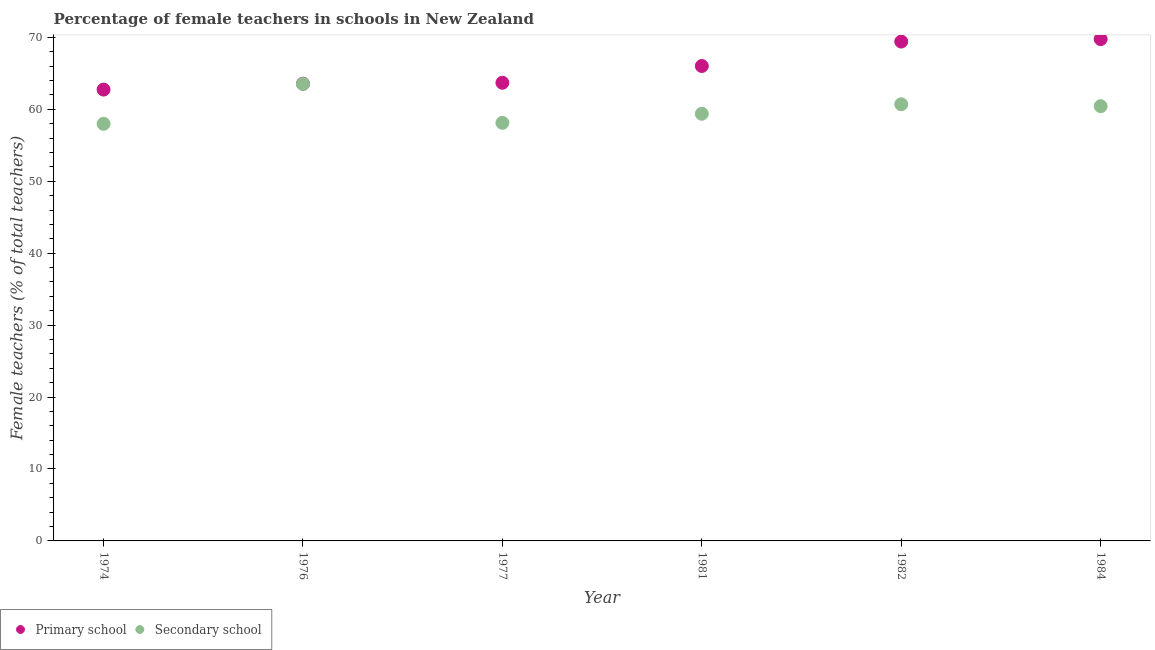Is the number of dotlines equal to the number of legend labels?
Your answer should be compact. Yes. What is the percentage of female teachers in secondary schools in 1984?
Ensure brevity in your answer.  60.43. Across all years, what is the maximum percentage of female teachers in secondary schools?
Keep it short and to the point. 63.51. Across all years, what is the minimum percentage of female teachers in secondary schools?
Your answer should be compact. 57.98. In which year was the percentage of female teachers in primary schools minimum?
Your response must be concise. 1974. What is the total percentage of female teachers in secondary schools in the graph?
Provide a succinct answer. 360.13. What is the difference between the percentage of female teachers in primary schools in 1976 and that in 1977?
Offer a terse response. -0.13. What is the difference between the percentage of female teachers in primary schools in 1974 and the percentage of female teachers in secondary schools in 1984?
Ensure brevity in your answer.  2.31. What is the average percentage of female teachers in primary schools per year?
Your answer should be compact. 65.86. In the year 1974, what is the difference between the percentage of female teachers in primary schools and percentage of female teachers in secondary schools?
Provide a short and direct response. 4.76. In how many years, is the percentage of female teachers in secondary schools greater than 28 %?
Provide a succinct answer. 6. What is the ratio of the percentage of female teachers in primary schools in 1977 to that in 1981?
Provide a short and direct response. 0.96. Is the percentage of female teachers in secondary schools in 1977 less than that in 1982?
Give a very brief answer. Yes. What is the difference between the highest and the second highest percentage of female teachers in primary schools?
Ensure brevity in your answer.  0.34. What is the difference between the highest and the lowest percentage of female teachers in secondary schools?
Provide a short and direct response. 5.53. Is the percentage of female teachers in primary schools strictly greater than the percentage of female teachers in secondary schools over the years?
Offer a very short reply. Yes. How many years are there in the graph?
Your answer should be compact. 6. What is the difference between two consecutive major ticks on the Y-axis?
Provide a short and direct response. 10. Are the values on the major ticks of Y-axis written in scientific E-notation?
Your answer should be very brief. No. How many legend labels are there?
Your response must be concise. 2. What is the title of the graph?
Your response must be concise. Percentage of female teachers in schools in New Zealand. Does "Primary education" appear as one of the legend labels in the graph?
Offer a terse response. No. What is the label or title of the X-axis?
Your answer should be compact. Year. What is the label or title of the Y-axis?
Your answer should be compact. Female teachers (% of total teachers). What is the Female teachers (% of total teachers) of Primary school in 1974?
Give a very brief answer. 62.74. What is the Female teachers (% of total teachers) of Secondary school in 1974?
Provide a succinct answer. 57.98. What is the Female teachers (% of total teachers) in Primary school in 1976?
Ensure brevity in your answer.  63.56. What is the Female teachers (% of total teachers) in Secondary school in 1976?
Offer a very short reply. 63.51. What is the Female teachers (% of total teachers) in Primary school in 1977?
Your answer should be compact. 63.69. What is the Female teachers (% of total teachers) in Secondary school in 1977?
Give a very brief answer. 58.12. What is the Female teachers (% of total teachers) of Primary school in 1981?
Your response must be concise. 66.02. What is the Female teachers (% of total teachers) of Secondary school in 1981?
Provide a short and direct response. 59.38. What is the Female teachers (% of total teachers) in Primary school in 1982?
Offer a terse response. 69.42. What is the Female teachers (% of total teachers) of Secondary school in 1982?
Your response must be concise. 60.7. What is the Female teachers (% of total teachers) of Primary school in 1984?
Give a very brief answer. 69.76. What is the Female teachers (% of total teachers) of Secondary school in 1984?
Provide a short and direct response. 60.43. Across all years, what is the maximum Female teachers (% of total teachers) of Primary school?
Keep it short and to the point. 69.76. Across all years, what is the maximum Female teachers (% of total teachers) in Secondary school?
Give a very brief answer. 63.51. Across all years, what is the minimum Female teachers (% of total teachers) of Primary school?
Provide a short and direct response. 62.74. Across all years, what is the minimum Female teachers (% of total teachers) of Secondary school?
Offer a very short reply. 57.98. What is the total Female teachers (% of total teachers) in Primary school in the graph?
Your answer should be compact. 395.19. What is the total Female teachers (% of total teachers) in Secondary school in the graph?
Ensure brevity in your answer.  360.13. What is the difference between the Female teachers (% of total teachers) of Primary school in 1974 and that in 1976?
Provide a succinct answer. -0.82. What is the difference between the Female teachers (% of total teachers) of Secondary school in 1974 and that in 1976?
Offer a very short reply. -5.53. What is the difference between the Female teachers (% of total teachers) of Primary school in 1974 and that in 1977?
Ensure brevity in your answer.  -0.95. What is the difference between the Female teachers (% of total teachers) of Secondary school in 1974 and that in 1977?
Make the answer very short. -0.13. What is the difference between the Female teachers (% of total teachers) in Primary school in 1974 and that in 1981?
Make the answer very short. -3.28. What is the difference between the Female teachers (% of total teachers) of Secondary school in 1974 and that in 1981?
Make the answer very short. -1.4. What is the difference between the Female teachers (% of total teachers) of Primary school in 1974 and that in 1982?
Offer a very short reply. -6.67. What is the difference between the Female teachers (% of total teachers) of Secondary school in 1974 and that in 1982?
Your response must be concise. -2.72. What is the difference between the Female teachers (% of total teachers) of Primary school in 1974 and that in 1984?
Offer a terse response. -7.02. What is the difference between the Female teachers (% of total teachers) in Secondary school in 1974 and that in 1984?
Your answer should be very brief. -2.45. What is the difference between the Female teachers (% of total teachers) of Primary school in 1976 and that in 1977?
Give a very brief answer. -0.13. What is the difference between the Female teachers (% of total teachers) in Secondary school in 1976 and that in 1977?
Offer a terse response. 5.4. What is the difference between the Female teachers (% of total teachers) of Primary school in 1976 and that in 1981?
Offer a very short reply. -2.45. What is the difference between the Female teachers (% of total teachers) in Secondary school in 1976 and that in 1981?
Provide a short and direct response. 4.13. What is the difference between the Female teachers (% of total teachers) of Primary school in 1976 and that in 1982?
Keep it short and to the point. -5.85. What is the difference between the Female teachers (% of total teachers) of Secondary school in 1976 and that in 1982?
Your response must be concise. 2.81. What is the difference between the Female teachers (% of total teachers) in Primary school in 1976 and that in 1984?
Provide a succinct answer. -6.19. What is the difference between the Female teachers (% of total teachers) in Secondary school in 1976 and that in 1984?
Provide a short and direct response. 3.08. What is the difference between the Female teachers (% of total teachers) of Primary school in 1977 and that in 1981?
Provide a short and direct response. -2.33. What is the difference between the Female teachers (% of total teachers) of Secondary school in 1977 and that in 1981?
Give a very brief answer. -1.26. What is the difference between the Female teachers (% of total teachers) in Primary school in 1977 and that in 1982?
Give a very brief answer. -5.73. What is the difference between the Female teachers (% of total teachers) in Secondary school in 1977 and that in 1982?
Keep it short and to the point. -2.58. What is the difference between the Female teachers (% of total teachers) of Primary school in 1977 and that in 1984?
Give a very brief answer. -6.07. What is the difference between the Female teachers (% of total teachers) in Secondary school in 1977 and that in 1984?
Your response must be concise. -2.32. What is the difference between the Female teachers (% of total teachers) of Primary school in 1981 and that in 1982?
Your answer should be compact. -3.4. What is the difference between the Female teachers (% of total teachers) of Secondary school in 1981 and that in 1982?
Provide a short and direct response. -1.32. What is the difference between the Female teachers (% of total teachers) of Primary school in 1981 and that in 1984?
Keep it short and to the point. -3.74. What is the difference between the Female teachers (% of total teachers) in Secondary school in 1981 and that in 1984?
Offer a very short reply. -1.05. What is the difference between the Female teachers (% of total teachers) of Primary school in 1982 and that in 1984?
Provide a short and direct response. -0.34. What is the difference between the Female teachers (% of total teachers) of Secondary school in 1982 and that in 1984?
Make the answer very short. 0.27. What is the difference between the Female teachers (% of total teachers) of Primary school in 1974 and the Female teachers (% of total teachers) of Secondary school in 1976?
Keep it short and to the point. -0.77. What is the difference between the Female teachers (% of total teachers) of Primary school in 1974 and the Female teachers (% of total teachers) of Secondary school in 1977?
Make the answer very short. 4.62. What is the difference between the Female teachers (% of total teachers) in Primary school in 1974 and the Female teachers (% of total teachers) in Secondary school in 1981?
Give a very brief answer. 3.36. What is the difference between the Female teachers (% of total teachers) of Primary school in 1974 and the Female teachers (% of total teachers) of Secondary school in 1982?
Provide a succinct answer. 2.04. What is the difference between the Female teachers (% of total teachers) of Primary school in 1974 and the Female teachers (% of total teachers) of Secondary school in 1984?
Make the answer very short. 2.31. What is the difference between the Female teachers (% of total teachers) in Primary school in 1976 and the Female teachers (% of total teachers) in Secondary school in 1977?
Provide a succinct answer. 5.45. What is the difference between the Female teachers (% of total teachers) of Primary school in 1976 and the Female teachers (% of total teachers) of Secondary school in 1981?
Offer a terse response. 4.18. What is the difference between the Female teachers (% of total teachers) of Primary school in 1976 and the Female teachers (% of total teachers) of Secondary school in 1982?
Give a very brief answer. 2.86. What is the difference between the Female teachers (% of total teachers) of Primary school in 1976 and the Female teachers (% of total teachers) of Secondary school in 1984?
Offer a terse response. 3.13. What is the difference between the Female teachers (% of total teachers) in Primary school in 1977 and the Female teachers (% of total teachers) in Secondary school in 1981?
Provide a short and direct response. 4.31. What is the difference between the Female teachers (% of total teachers) in Primary school in 1977 and the Female teachers (% of total teachers) in Secondary school in 1982?
Ensure brevity in your answer.  2.99. What is the difference between the Female teachers (% of total teachers) in Primary school in 1977 and the Female teachers (% of total teachers) in Secondary school in 1984?
Your answer should be very brief. 3.26. What is the difference between the Female teachers (% of total teachers) of Primary school in 1981 and the Female teachers (% of total teachers) of Secondary school in 1982?
Your answer should be very brief. 5.32. What is the difference between the Female teachers (% of total teachers) in Primary school in 1981 and the Female teachers (% of total teachers) in Secondary school in 1984?
Give a very brief answer. 5.59. What is the difference between the Female teachers (% of total teachers) of Primary school in 1982 and the Female teachers (% of total teachers) of Secondary school in 1984?
Your response must be concise. 8.98. What is the average Female teachers (% of total teachers) of Primary school per year?
Provide a short and direct response. 65.86. What is the average Female teachers (% of total teachers) in Secondary school per year?
Make the answer very short. 60.02. In the year 1974, what is the difference between the Female teachers (% of total teachers) in Primary school and Female teachers (% of total teachers) in Secondary school?
Keep it short and to the point. 4.76. In the year 1976, what is the difference between the Female teachers (% of total teachers) in Primary school and Female teachers (% of total teachers) in Secondary school?
Offer a very short reply. 0.05. In the year 1977, what is the difference between the Female teachers (% of total teachers) of Primary school and Female teachers (% of total teachers) of Secondary school?
Offer a terse response. 5.57. In the year 1981, what is the difference between the Female teachers (% of total teachers) in Primary school and Female teachers (% of total teachers) in Secondary school?
Give a very brief answer. 6.64. In the year 1982, what is the difference between the Female teachers (% of total teachers) in Primary school and Female teachers (% of total teachers) in Secondary school?
Offer a terse response. 8.72. In the year 1984, what is the difference between the Female teachers (% of total teachers) in Primary school and Female teachers (% of total teachers) in Secondary school?
Your answer should be compact. 9.32. What is the ratio of the Female teachers (% of total teachers) of Secondary school in 1974 to that in 1976?
Ensure brevity in your answer.  0.91. What is the ratio of the Female teachers (% of total teachers) of Primary school in 1974 to that in 1977?
Make the answer very short. 0.99. What is the ratio of the Female teachers (% of total teachers) of Secondary school in 1974 to that in 1977?
Offer a very short reply. 1. What is the ratio of the Female teachers (% of total teachers) in Primary school in 1974 to that in 1981?
Provide a short and direct response. 0.95. What is the ratio of the Female teachers (% of total teachers) in Secondary school in 1974 to that in 1981?
Provide a short and direct response. 0.98. What is the ratio of the Female teachers (% of total teachers) in Primary school in 1974 to that in 1982?
Provide a short and direct response. 0.9. What is the ratio of the Female teachers (% of total teachers) in Secondary school in 1974 to that in 1982?
Give a very brief answer. 0.96. What is the ratio of the Female teachers (% of total teachers) in Primary school in 1974 to that in 1984?
Provide a short and direct response. 0.9. What is the ratio of the Female teachers (% of total teachers) of Secondary school in 1974 to that in 1984?
Give a very brief answer. 0.96. What is the ratio of the Female teachers (% of total teachers) of Secondary school in 1976 to that in 1977?
Provide a succinct answer. 1.09. What is the ratio of the Female teachers (% of total teachers) in Primary school in 1976 to that in 1981?
Your answer should be compact. 0.96. What is the ratio of the Female teachers (% of total teachers) in Secondary school in 1976 to that in 1981?
Make the answer very short. 1.07. What is the ratio of the Female teachers (% of total teachers) of Primary school in 1976 to that in 1982?
Provide a succinct answer. 0.92. What is the ratio of the Female teachers (% of total teachers) in Secondary school in 1976 to that in 1982?
Offer a very short reply. 1.05. What is the ratio of the Female teachers (% of total teachers) in Primary school in 1976 to that in 1984?
Keep it short and to the point. 0.91. What is the ratio of the Female teachers (% of total teachers) in Secondary school in 1976 to that in 1984?
Keep it short and to the point. 1.05. What is the ratio of the Female teachers (% of total teachers) in Primary school in 1977 to that in 1981?
Make the answer very short. 0.96. What is the ratio of the Female teachers (% of total teachers) of Secondary school in 1977 to that in 1981?
Provide a short and direct response. 0.98. What is the ratio of the Female teachers (% of total teachers) in Primary school in 1977 to that in 1982?
Make the answer very short. 0.92. What is the ratio of the Female teachers (% of total teachers) of Secondary school in 1977 to that in 1982?
Your response must be concise. 0.96. What is the ratio of the Female teachers (% of total teachers) of Primary school in 1977 to that in 1984?
Offer a terse response. 0.91. What is the ratio of the Female teachers (% of total teachers) of Secondary school in 1977 to that in 1984?
Ensure brevity in your answer.  0.96. What is the ratio of the Female teachers (% of total teachers) in Primary school in 1981 to that in 1982?
Offer a terse response. 0.95. What is the ratio of the Female teachers (% of total teachers) of Secondary school in 1981 to that in 1982?
Ensure brevity in your answer.  0.98. What is the ratio of the Female teachers (% of total teachers) in Primary school in 1981 to that in 1984?
Offer a very short reply. 0.95. What is the ratio of the Female teachers (% of total teachers) of Secondary school in 1981 to that in 1984?
Your answer should be compact. 0.98. What is the ratio of the Female teachers (% of total teachers) in Primary school in 1982 to that in 1984?
Make the answer very short. 1. What is the ratio of the Female teachers (% of total teachers) in Secondary school in 1982 to that in 1984?
Make the answer very short. 1. What is the difference between the highest and the second highest Female teachers (% of total teachers) of Primary school?
Ensure brevity in your answer.  0.34. What is the difference between the highest and the second highest Female teachers (% of total teachers) of Secondary school?
Your answer should be compact. 2.81. What is the difference between the highest and the lowest Female teachers (% of total teachers) of Primary school?
Your response must be concise. 7.02. What is the difference between the highest and the lowest Female teachers (% of total teachers) of Secondary school?
Your answer should be compact. 5.53. 